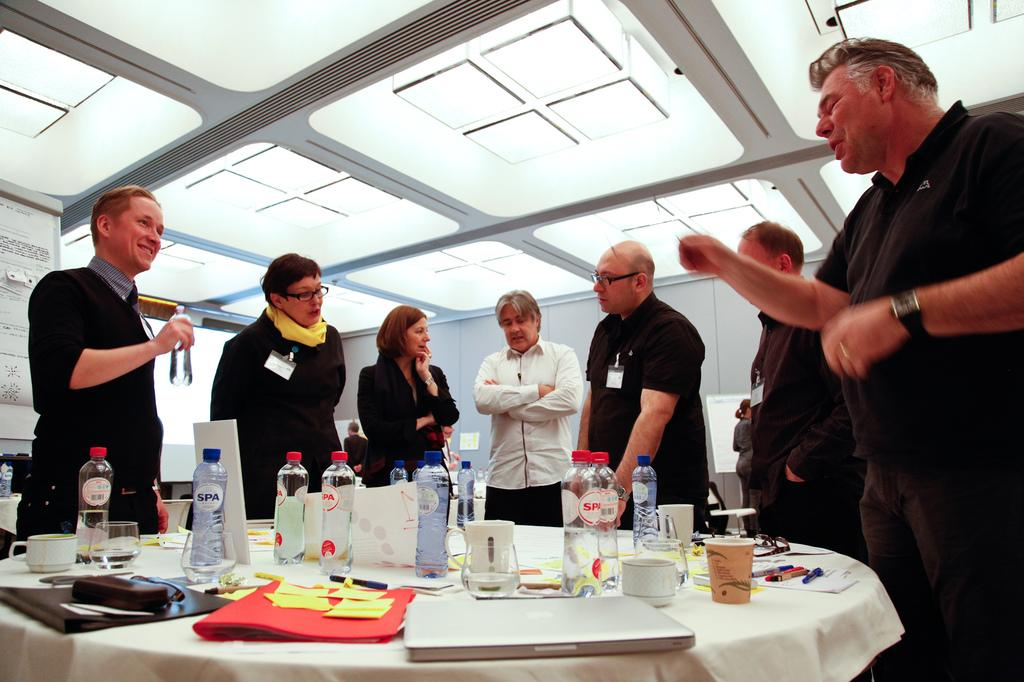What can be seen in the image involving people? There are people standing in the image. What electronic device is present on the table? There is a laptop on the table. What type of beverage container is on the table? There are water bottles on the table. What stationery item is on the table? There is a pen on the table. What type of document is on the table? There is a file on the table. What can be used for writing on the paper? There is a pen on the table. What type of authority figure is present in the image? There is no authority figure present in the image. What type of porter can be seen carrying luggage in the image? There is no porter or luggage present in the image. 